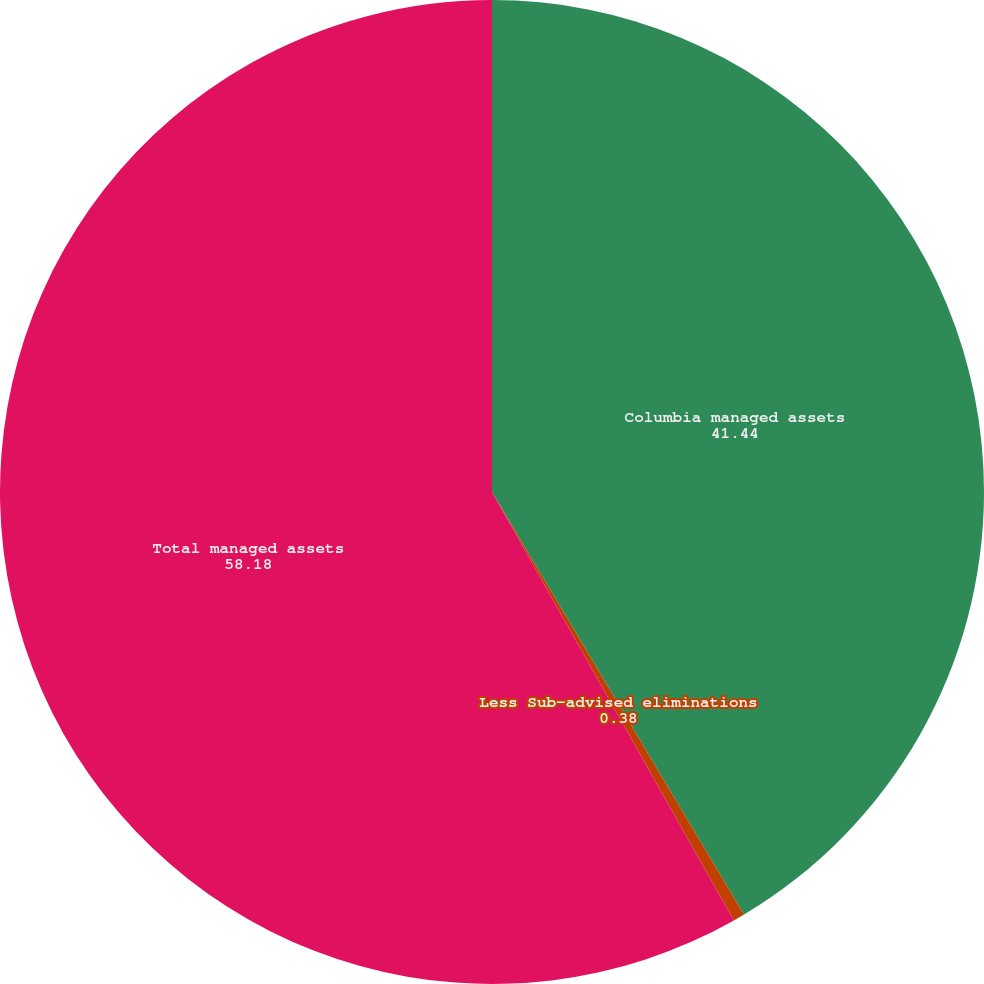Convert chart to OTSL. <chart><loc_0><loc_0><loc_500><loc_500><pie_chart><fcel>Columbia managed assets<fcel>Less Sub-advised eliminations<fcel>Total managed assets<nl><fcel>41.44%<fcel>0.38%<fcel>58.18%<nl></chart> 